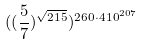Convert formula to latex. <formula><loc_0><loc_0><loc_500><loc_500>( ( \frac { 5 } { 7 } ) ^ { \sqrt { 2 1 5 } } ) ^ { 2 6 0 \cdot 4 1 0 ^ { 2 0 7 } }</formula> 